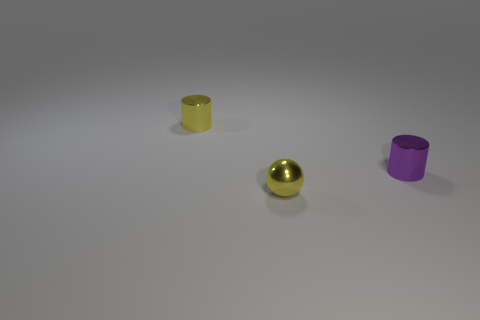How many things are small cylinders on the left side of the shiny ball or tiny objects that are to the left of the yellow ball?
Keep it short and to the point. 1. There is a yellow sphere that is on the left side of the purple metal thing; are there any small purple shiny things that are left of it?
Your response must be concise. No. There is a yellow object that is the same size as the yellow metallic cylinder; what shape is it?
Offer a terse response. Sphere. What number of objects are either tiny cylinders that are on the right side of the yellow metallic cylinder or small yellow metallic spheres?
Your answer should be compact. 2. What number of other objects are there of the same material as the tiny purple thing?
Ensure brevity in your answer.  2. The tiny metal thing that is the same color as the small sphere is what shape?
Ensure brevity in your answer.  Cylinder. What shape is the tiny purple thing that is made of the same material as the yellow cylinder?
Your response must be concise. Cylinder. Is the shape of the metal object behind the purple thing the same as  the purple thing?
Keep it short and to the point. Yes. There is a purple object; is it the same shape as the small metal object that is on the left side of the tiny metal sphere?
Your response must be concise. Yes. What is the color of the tiny metal object that is behind the small yellow metallic ball and on the left side of the purple shiny object?
Your response must be concise. Yellow. 